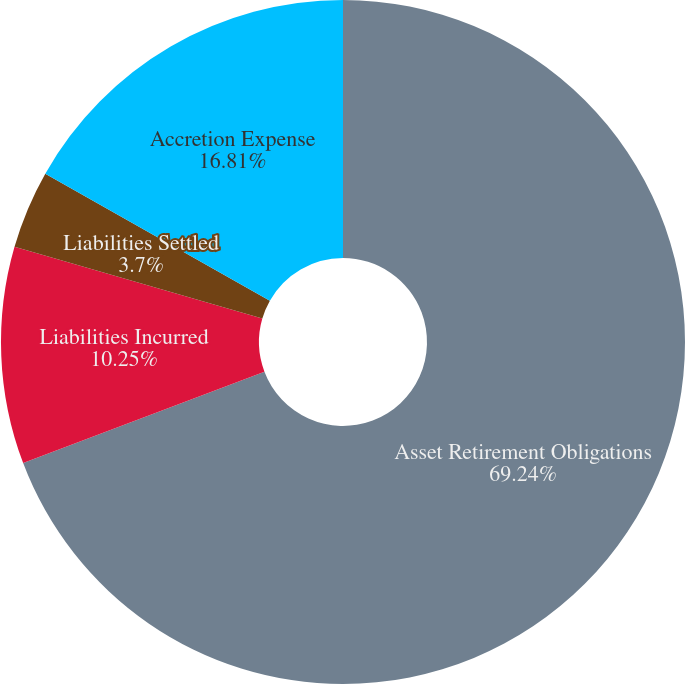Convert chart to OTSL. <chart><loc_0><loc_0><loc_500><loc_500><pie_chart><fcel>Asset Retirement Obligations<fcel>Liabilities Incurred<fcel>Liabilities Settled<fcel>Accretion Expense<nl><fcel>69.24%<fcel>10.25%<fcel>3.7%<fcel>16.81%<nl></chart> 